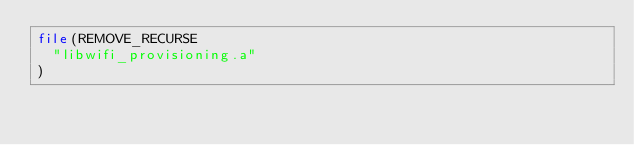Convert code to text. <code><loc_0><loc_0><loc_500><loc_500><_CMake_>file(REMOVE_RECURSE
  "libwifi_provisioning.a"
)
</code> 